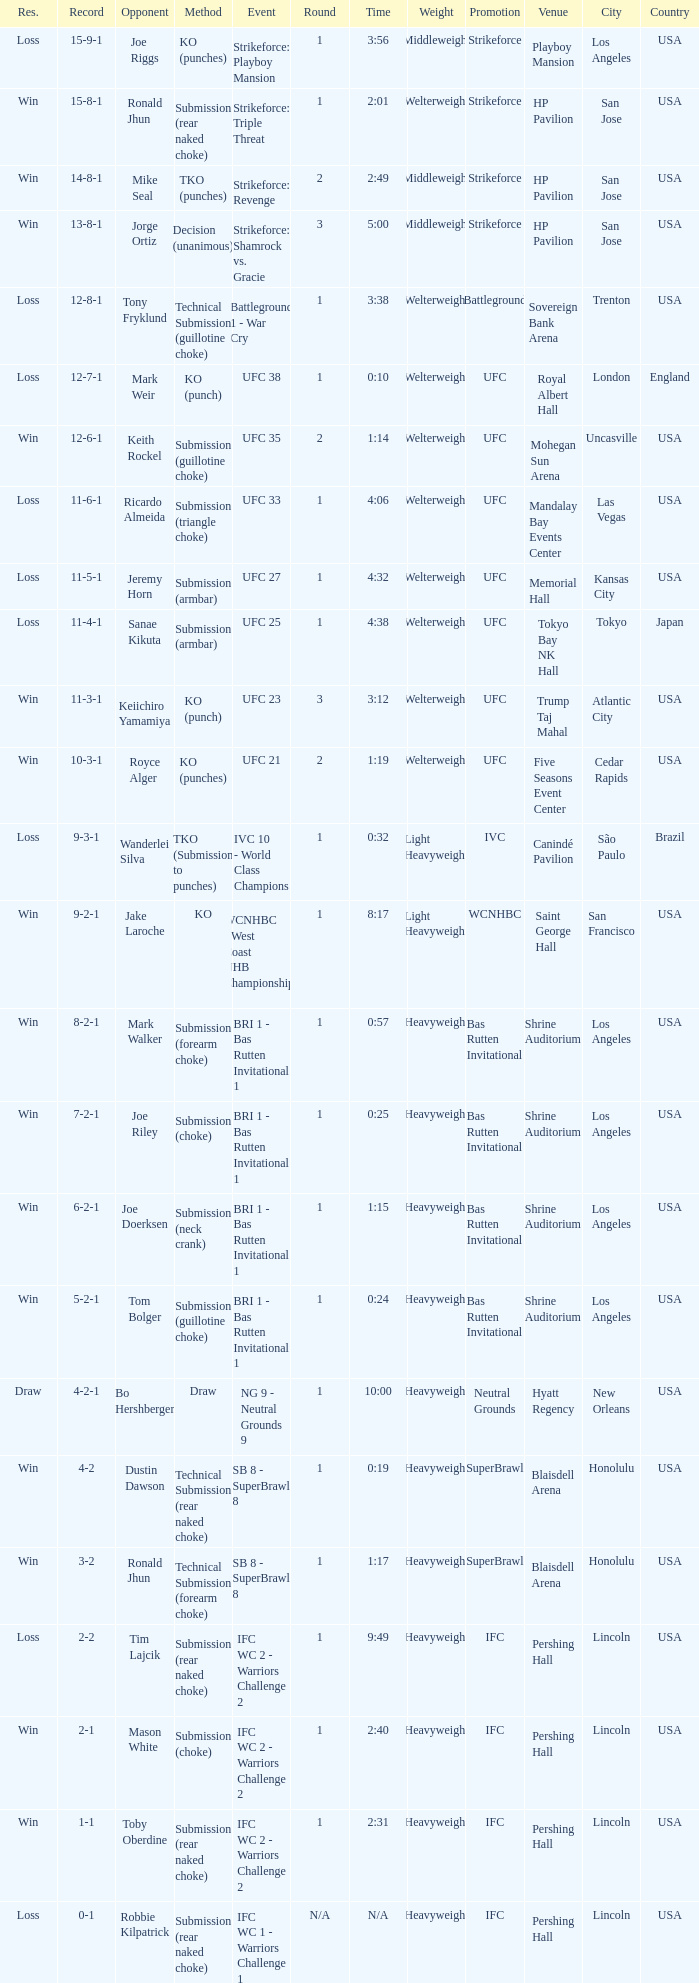What was the resolution for the fight against tom bolger by submission (guillotine choke)? Win. 